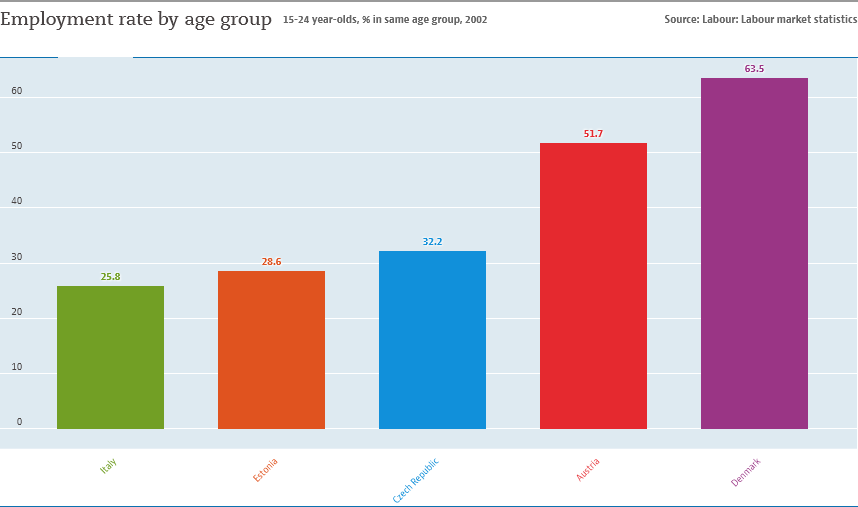Give some essential details in this illustration. The average of Italy and Denmark is approximately 44.65. There are 5 color bars in the graph. 